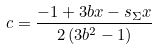<formula> <loc_0><loc_0><loc_500><loc_500>c = \frac { - 1 + 3 b x - s _ { \Sigma } x } { 2 \left ( 3 b ^ { 2 } - 1 \right ) }</formula> 